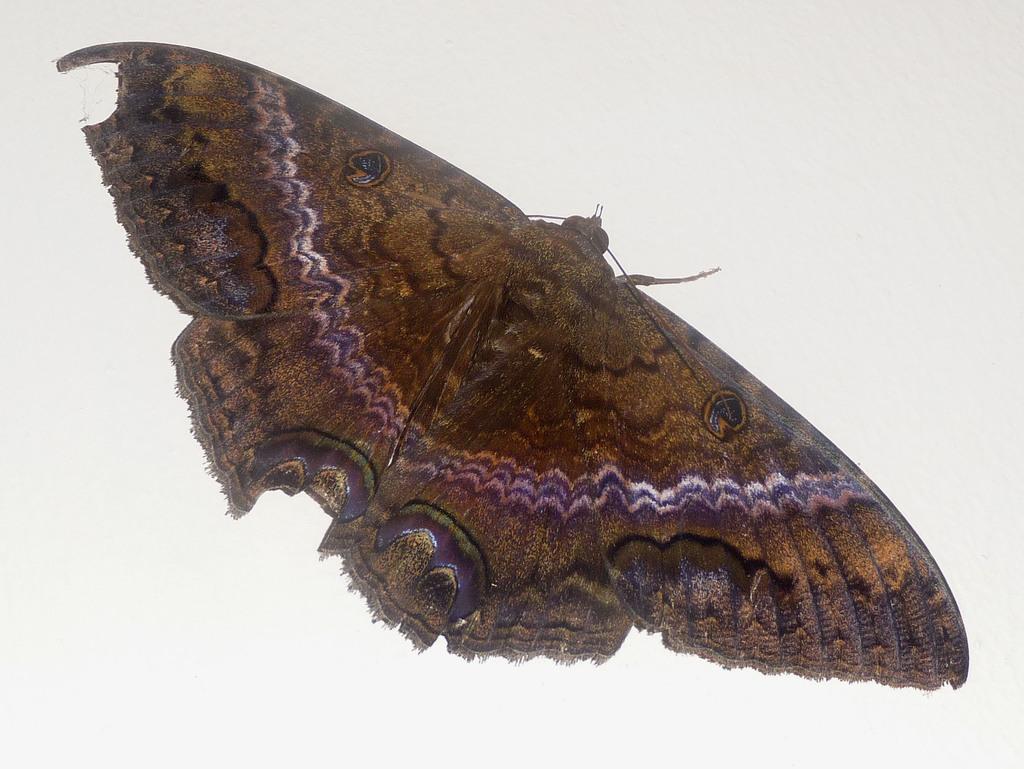In one or two sentences, can you explain what this image depicts? This picture contains a butterfly. It is in brown color. In the background, it is in white color. 